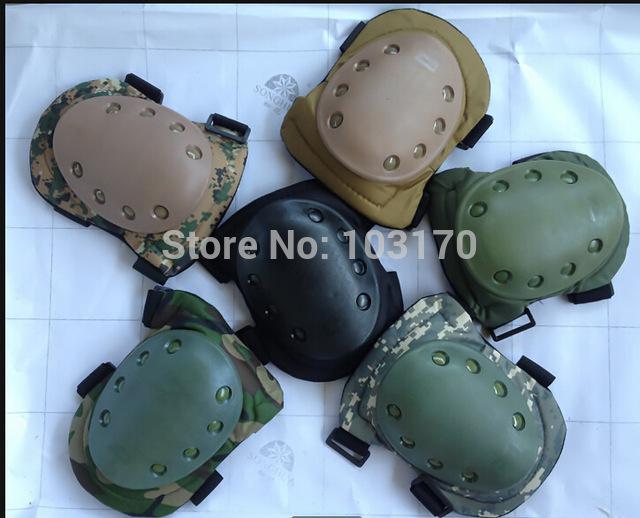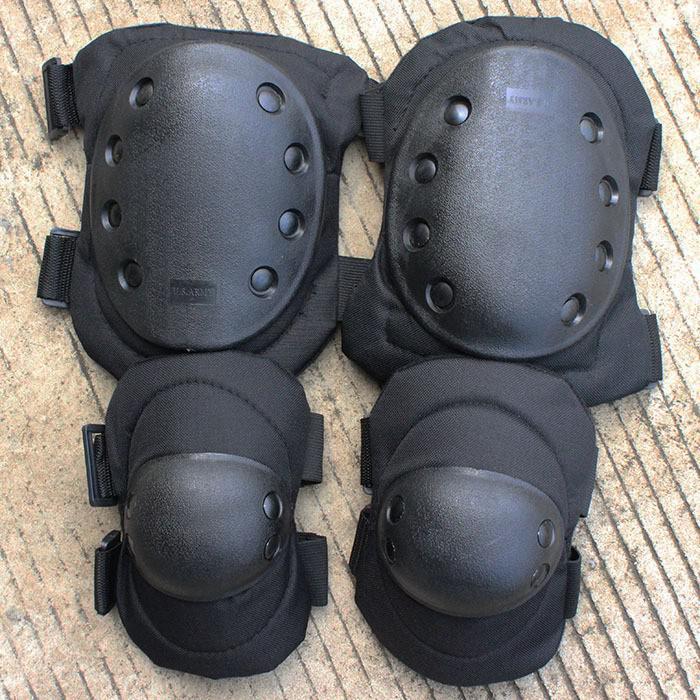The first image is the image on the left, the second image is the image on the right. For the images displayed, is the sentence "The right image contains exactly two pairs of black pads arranged with one pair above the other." factually correct? Answer yes or no. Yes. The first image is the image on the left, the second image is the image on the right. Given the left and right images, does the statement "Some knee pads have a camouflage design." hold true? Answer yes or no. Yes. 